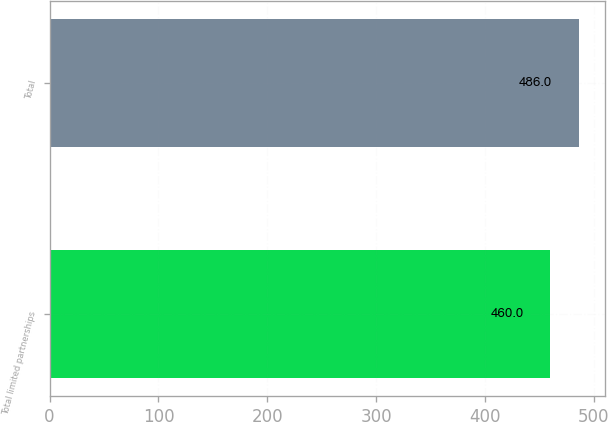Convert chart. <chart><loc_0><loc_0><loc_500><loc_500><bar_chart><fcel>Total limited partnerships<fcel>Total<nl><fcel>460<fcel>486<nl></chart> 